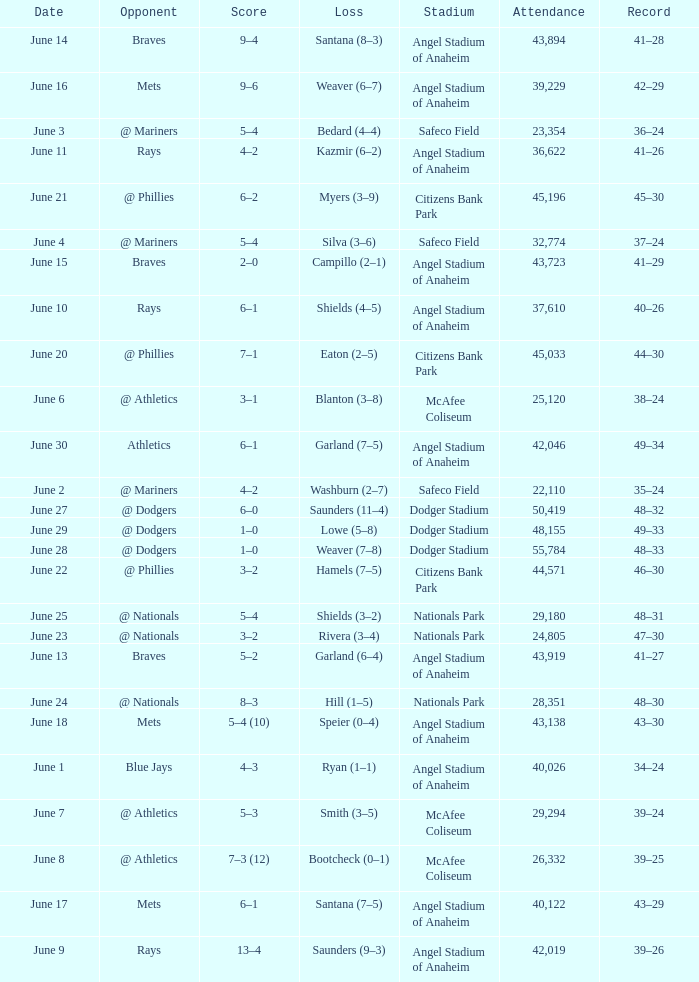What was the score of the game against the Braves with a record of 41–27? 5–2. 